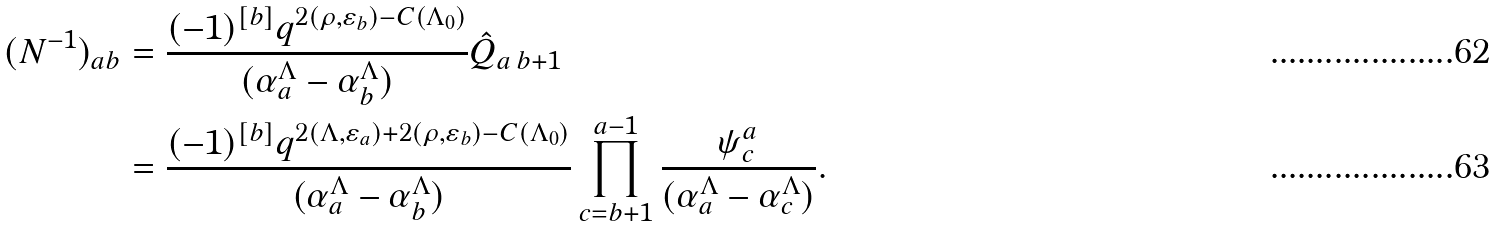<formula> <loc_0><loc_0><loc_500><loc_500>( N ^ { - 1 } ) _ { a b } & = \frac { ( - 1 ) ^ { [ b ] } q ^ { 2 ( \rho , \varepsilon _ { b } ) - C ( \Lambda _ { 0 } ) } } { ( \alpha _ { a } ^ { \Lambda } - \alpha _ { b } ^ { \Lambda } ) } \hat { Q } _ { a \, b + 1 } \\ & = \frac { ( - 1 ) ^ { [ b ] } q ^ { 2 ( \Lambda , \varepsilon _ { a } ) + 2 ( \rho , \varepsilon _ { b } ) - C ( \Lambda _ { 0 } ) } } { ( \alpha _ { a } ^ { \Lambda } - \alpha _ { b } ^ { \Lambda } ) } \prod _ { c = b + 1 } ^ { a - 1 } \frac { \psi ^ { a } _ { c } } { ( \alpha _ { a } ^ { \Lambda } - \alpha _ { c } ^ { \Lambda } ) } .</formula> 